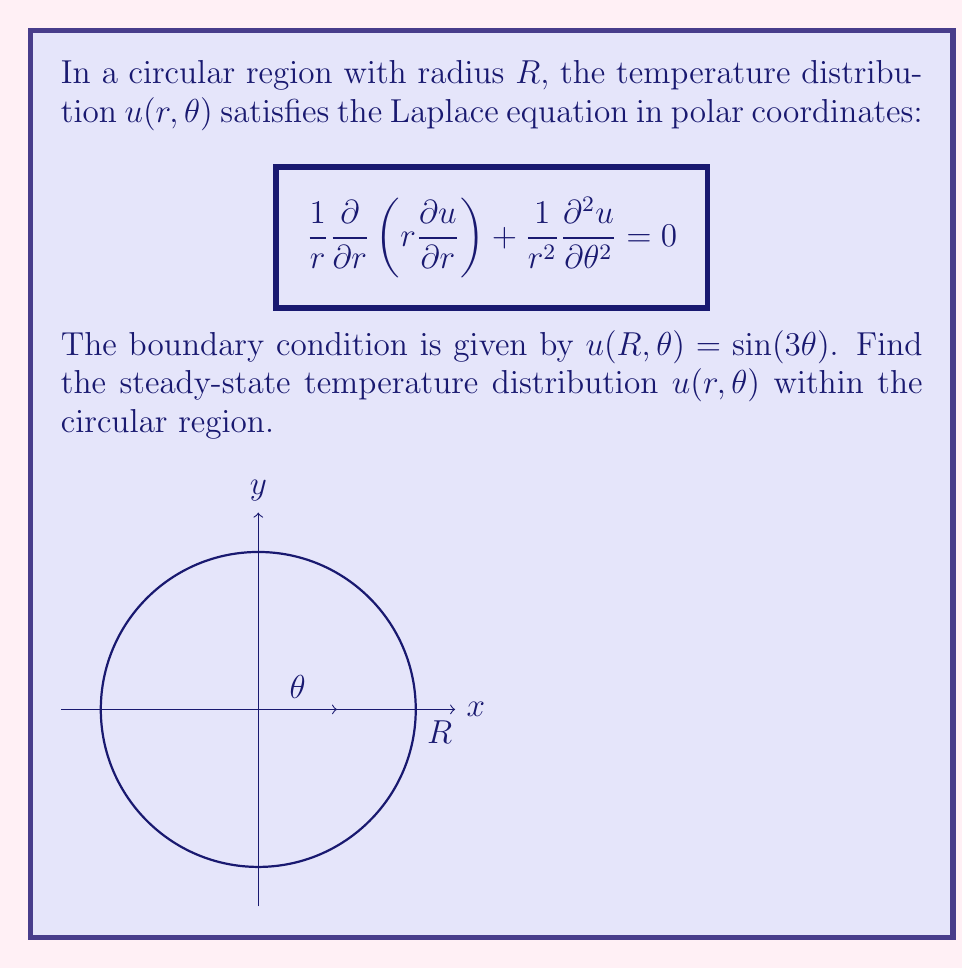Solve this math problem. To solve this problem, we'll follow these steps:

1) The general solution to the Laplace equation in polar coordinates is:

   $$u(r,\theta) = \sum_{n=0}^{\infty} (A_n r^n + B_n r^{-n})(C_n \cos(n\theta) + D_n \sin(n\theta))$$

2) Since the solution must be finite at $r=0$, we can eliminate the $r^{-n}$ terms:

   $$u(r,\theta) = \sum_{n=0}^{\infty} r^n(C_n \cos(n\theta) + D_n \sin(n\theta))$$

3) The boundary condition $u(R,\theta) = \sin(3\theta)$ implies that only the $n=3$ term will be non-zero, and only the sine term will be present:

   $$u(r,\theta) = A r^3 \sin(3\theta)$$

4) To determine $A$, we apply the boundary condition:

   $$u(R,\theta) = A R^3 \sin(3\theta) = \sin(3\theta)$$

5) This implies that $A R^3 = 1$, or $A = \frac{1}{R^3}$.

Therefore, the final solution is:

$$u(r,\theta) = \frac{r^3}{R^3} \sin(3\theta)$$

This solution satisfies the Laplace equation and the given boundary condition.
Answer: $$u(r,\theta) = \frac{r^3}{R^3} \sin(3\theta)$$ 